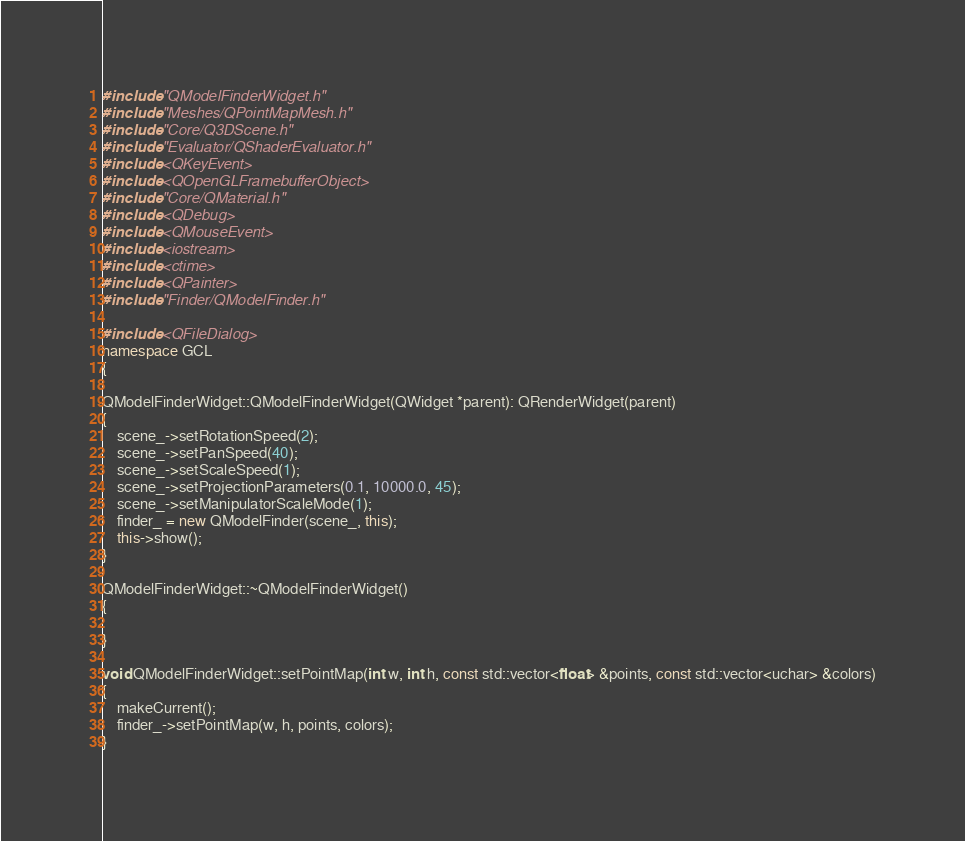Convert code to text. <code><loc_0><loc_0><loc_500><loc_500><_C++_>#include "QModelFinderWidget.h"
#include "Meshes/QPointMapMesh.h"
#include "Core/Q3DScene.h"
#include "Evaluator/QShaderEvaluator.h"
#include <QKeyEvent>
#include <QOpenGLFramebufferObject>
#include "Core/QMaterial.h"
#include <QDebug>
#include <QMouseEvent>
#include <iostream>
#include <ctime>
#include <QPainter>
#include "Finder/QModelFinder.h"

#include <QFileDialog>
namespace GCL
{

QModelFinderWidget::QModelFinderWidget(QWidget *parent): QRenderWidget(parent)
{
    scene_->setRotationSpeed(2);
    scene_->setPanSpeed(40);
    scene_->setScaleSpeed(1);
    scene_->setProjectionParameters(0.1, 10000.0, 45);
    scene_->setManipulatorScaleMode(1);
    finder_ = new QModelFinder(scene_, this);
    this->show();
}

QModelFinderWidget::~QModelFinderWidget()
{

}

void QModelFinderWidget::setPointMap(int w, int h, const std::vector<float> &points, const std::vector<uchar> &colors)
{
    makeCurrent();
    finder_->setPointMap(w, h, points, colors);
}
</code> 